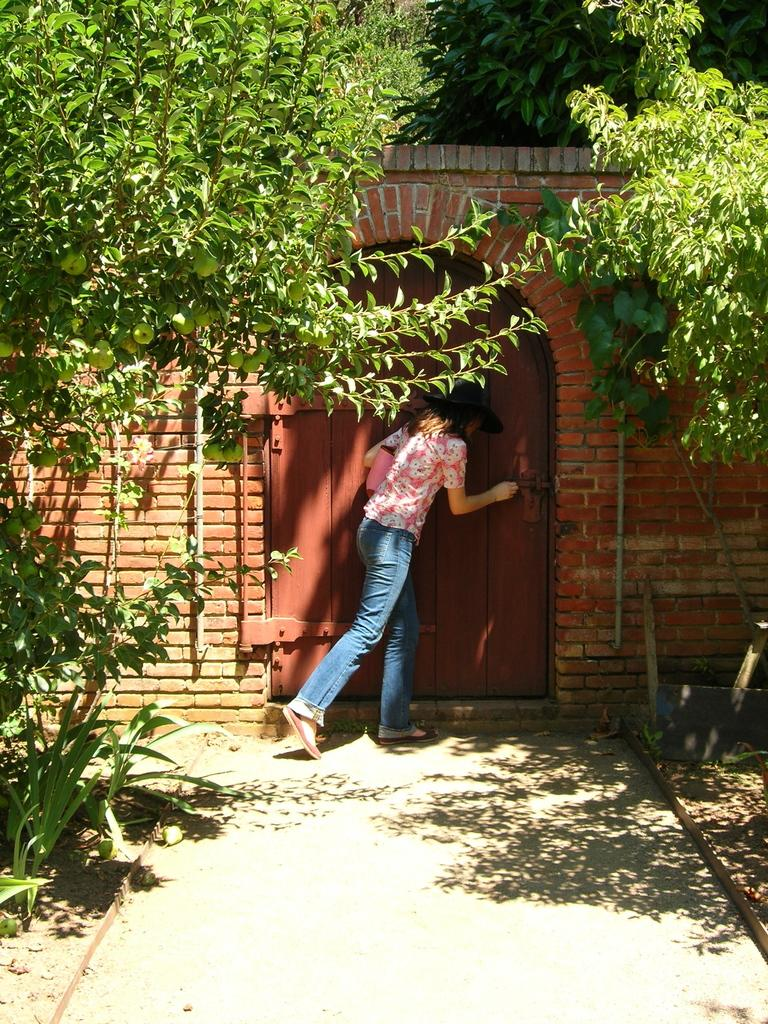What is the woman in the image doing? The woman is standing near the gate in the image. What type of vegetation can be seen in the image? Trees and shrubs are present in the image. What can be found on the trees in the image? Fruits are visible on the trees in the image. What architectural feature is present in the image? There is a wall in the image. Can you see any cobwebs on the wall in the image? There is no mention of cobwebs in the image, so we cannot determine if they are present or not. 